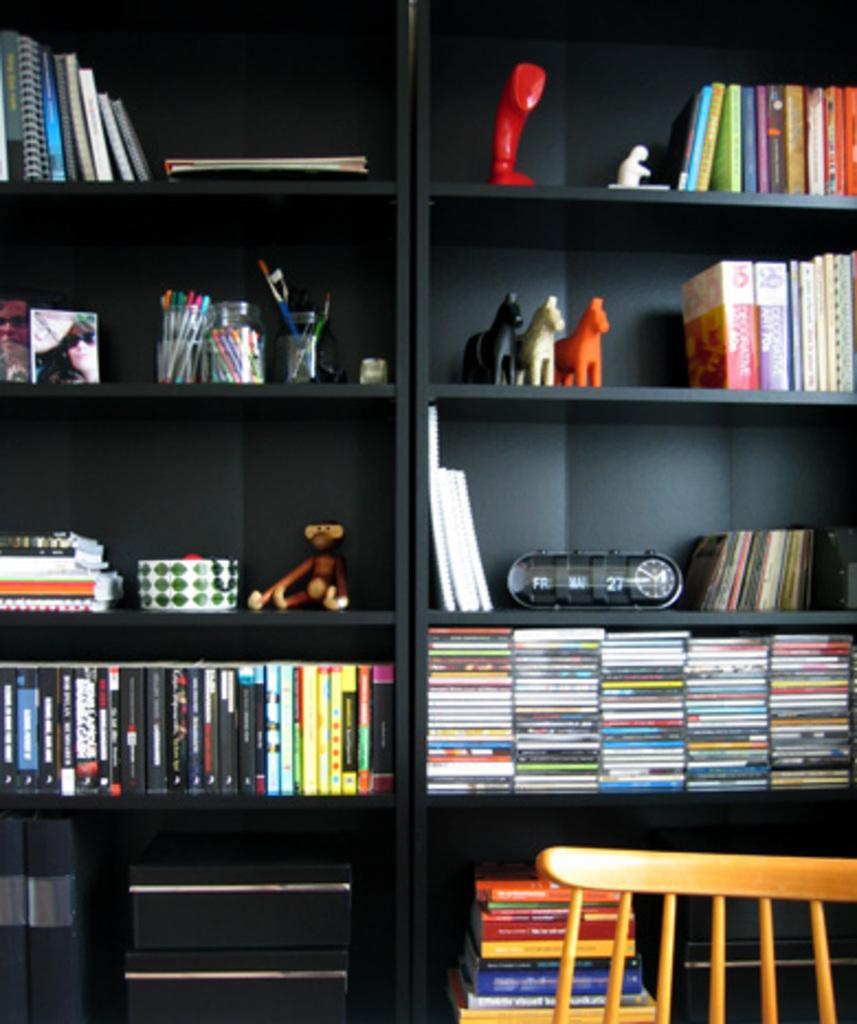What type of furniture is visible in the image? There is a cupboard with racks in the image. What items can be found inside the cupboard? There are books, toys, photo frames, and boxes with pens inside the cupboard. Are there any other items inside the cupboard? Yes, there are other items inside the cupboard. What is located at the bottom of the image? There is a chair at the bottom of the image. What type of noise is the monkey making in the image? There is no monkey present in the image, so it is not possible to determine what noise it might be making. 